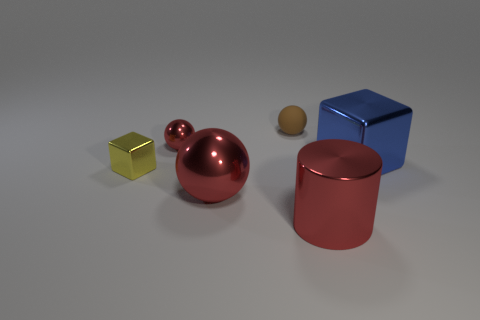There is a red sphere that is behind the red ball in front of the tiny yellow metal object; what number of large red cylinders are behind it?
Ensure brevity in your answer.  0. How many big purple cylinders are there?
Make the answer very short. 0. Is the number of small matte balls left of the yellow block less than the number of small shiny spheres in front of the big shiny cube?
Your response must be concise. No. Is the number of large things that are in front of the cylinder less than the number of small red spheres?
Provide a succinct answer. Yes. What material is the red ball behind the tiny yellow metal block in front of the tiny shiny thing on the right side of the small yellow metallic object?
Your answer should be compact. Metal. How many things are either large red objects right of the big ball or balls in front of the small brown object?
Give a very brief answer. 3. There is a blue thing that is the same shape as the yellow shiny object; what material is it?
Make the answer very short. Metal. Are there an equal number of large blue objects and cyan matte cylinders?
Offer a terse response. No. What number of metallic objects are either brown objects or small red spheres?
Your answer should be very brief. 1. The tiny yellow thing that is the same material as the big blue block is what shape?
Ensure brevity in your answer.  Cube. 